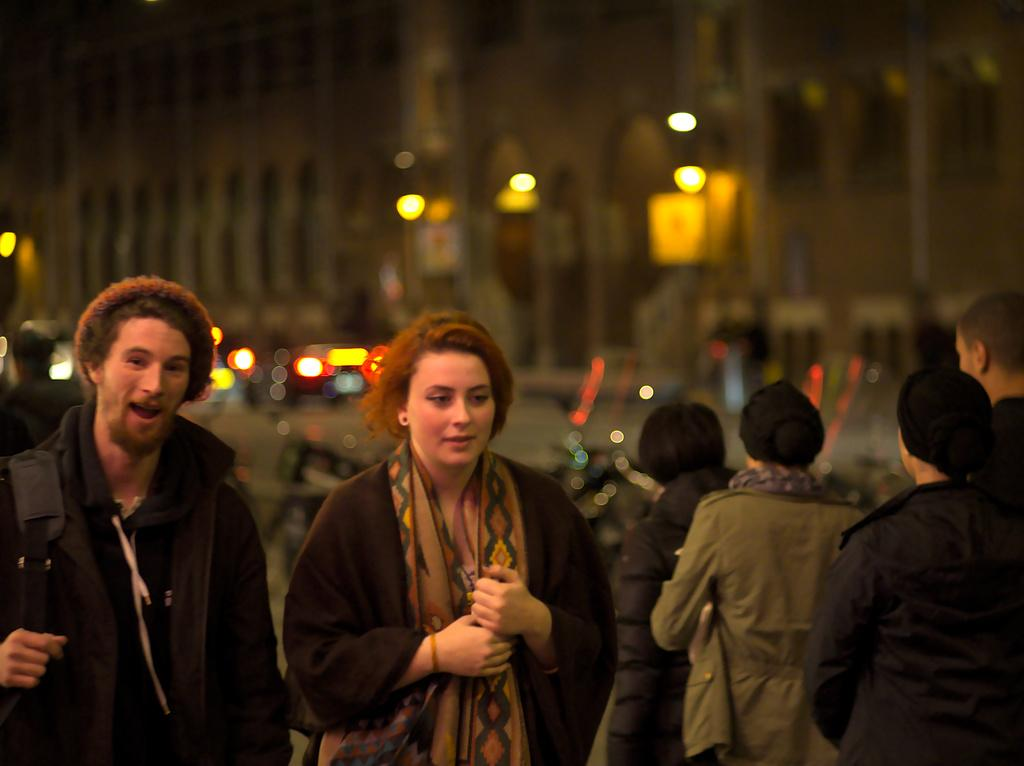What are the people in the image doing? The groups of people are standing. What can be seen in the distance behind the people? There are buildings, vehicles, and lights visible in the background. What year is depicted in the image? The year is not visible or mentioned in the image, so it cannot be determined. 